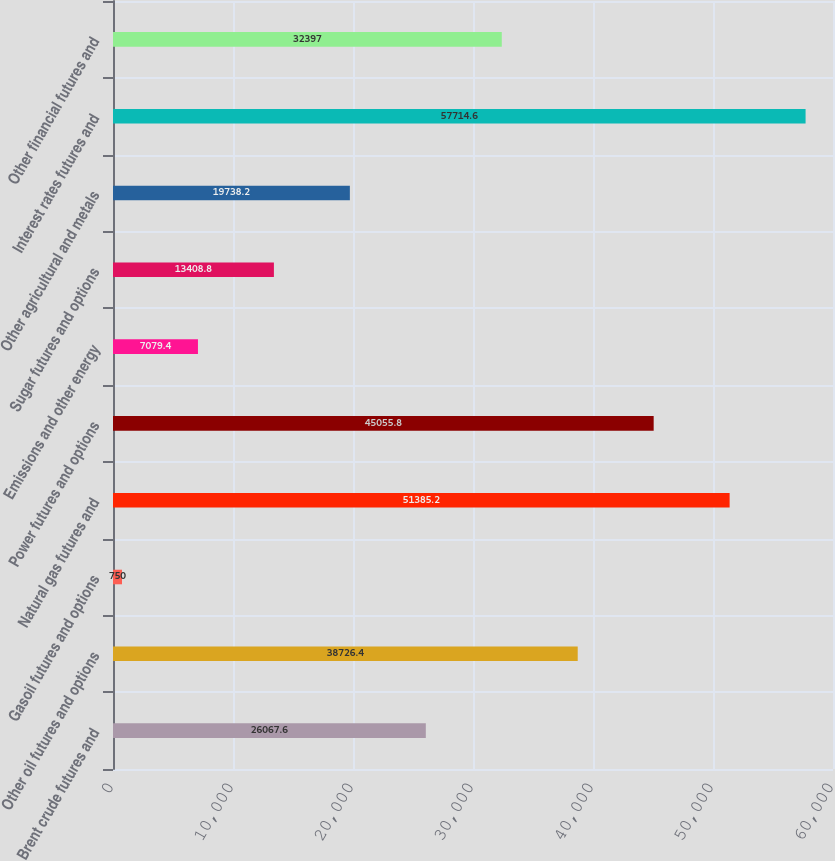Convert chart. <chart><loc_0><loc_0><loc_500><loc_500><bar_chart><fcel>Brent crude futures and<fcel>Other oil futures and options<fcel>Gasoil futures and options<fcel>Natural gas futures and<fcel>Power futures and options<fcel>Emissions and other energy<fcel>Sugar futures and options<fcel>Other agricultural and metals<fcel>Interest rates futures and<fcel>Other financial futures and<nl><fcel>26067.6<fcel>38726.4<fcel>750<fcel>51385.2<fcel>45055.8<fcel>7079.4<fcel>13408.8<fcel>19738.2<fcel>57714.6<fcel>32397<nl></chart> 